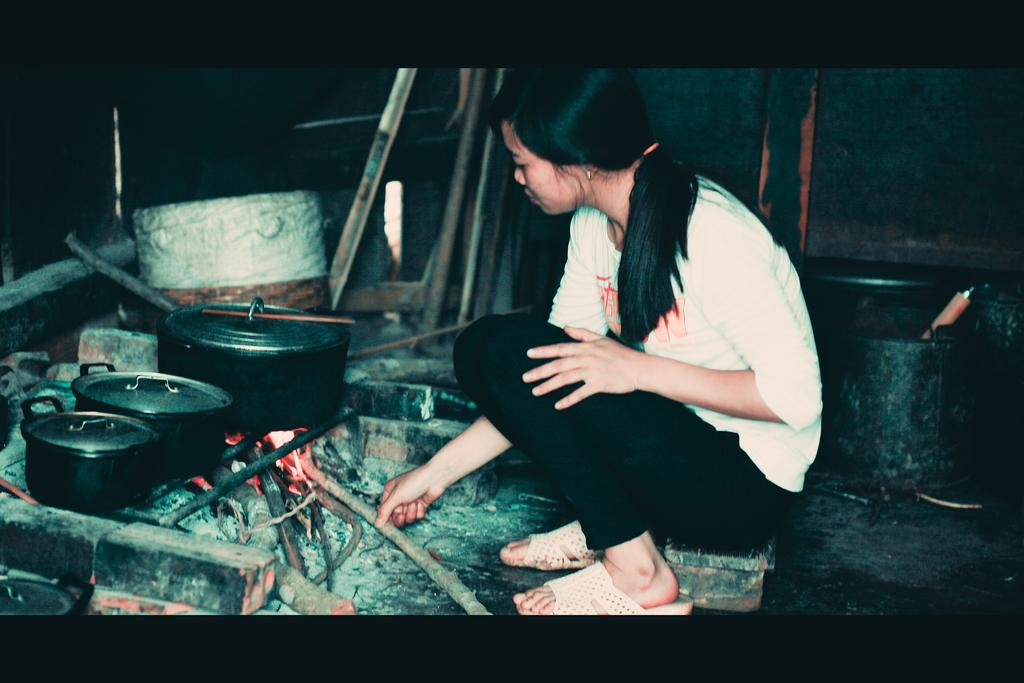What is the woman doing in the image? The woman is sitting in the image. What is the woman holding in the image? The woman is holding a wooden stick in the image. What is happening with the wooden stick in the image? The wooden stick is being used to control the fire visible in the image. What objects are present for cooking purposes in the image? There are cooking containers in the image. What type of behavior is the potato exhibiting in the image? There is no potato present in the image, so its behavior cannot be observed or described. 